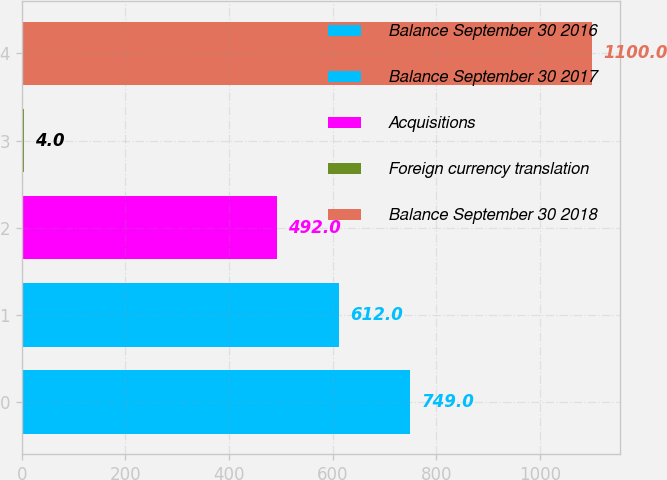<chart> <loc_0><loc_0><loc_500><loc_500><bar_chart><fcel>Balance September 30 2016<fcel>Balance September 30 2017<fcel>Acquisitions<fcel>Foreign currency translation<fcel>Balance September 30 2018<nl><fcel>749<fcel>612<fcel>492<fcel>4<fcel>1100<nl></chart> 